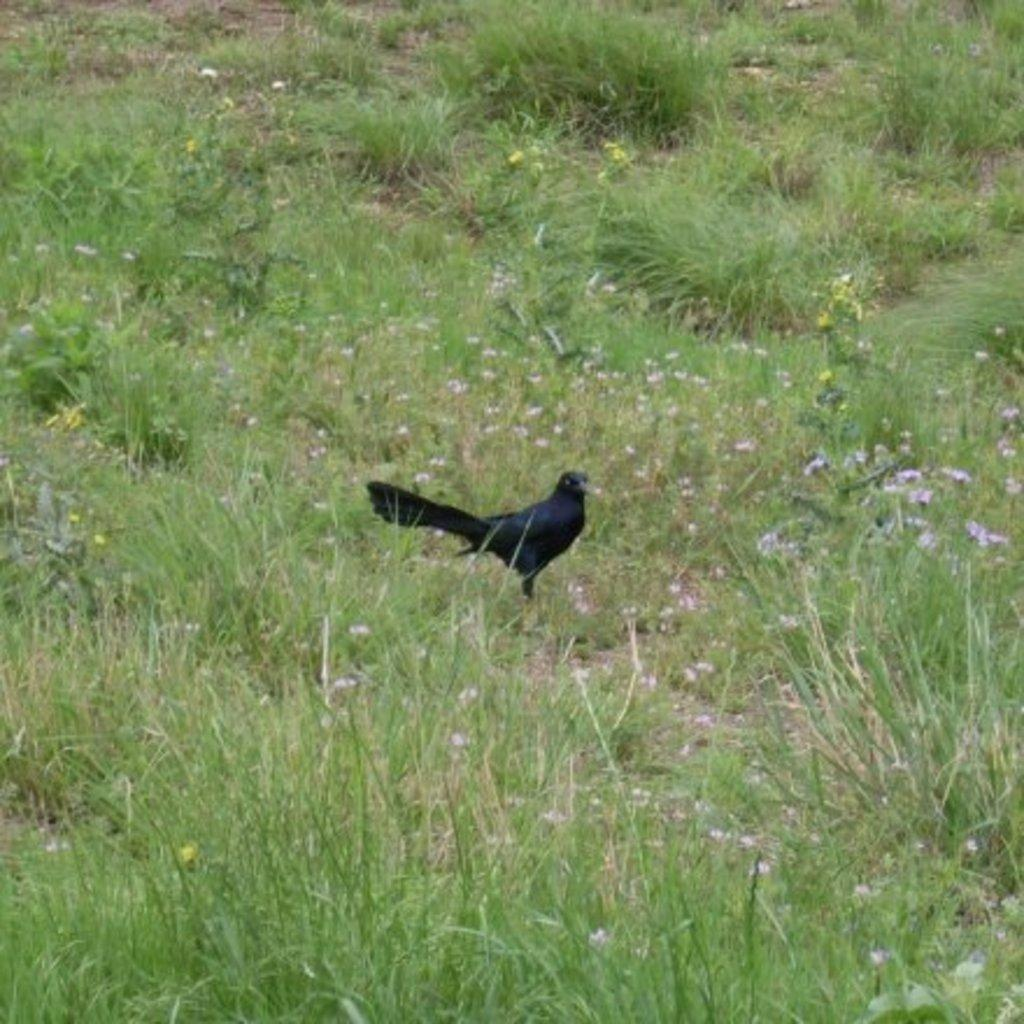What type of surface is visible in the image? There is a grass surface in the image. What can be found on the grass surface? Grass plants are present on the grass surface. What type of animal is in the image? There is a bird in the image. What is the color of the bird? The bird is black in color. What type of shop can be seen on the edge of the grass surface in the image? There is no shop present in the image; it only features a grass surface, grass plants, and a black bird. 